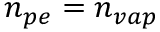<formula> <loc_0><loc_0><loc_500><loc_500>n _ { p e } = n _ { v a p }</formula> 